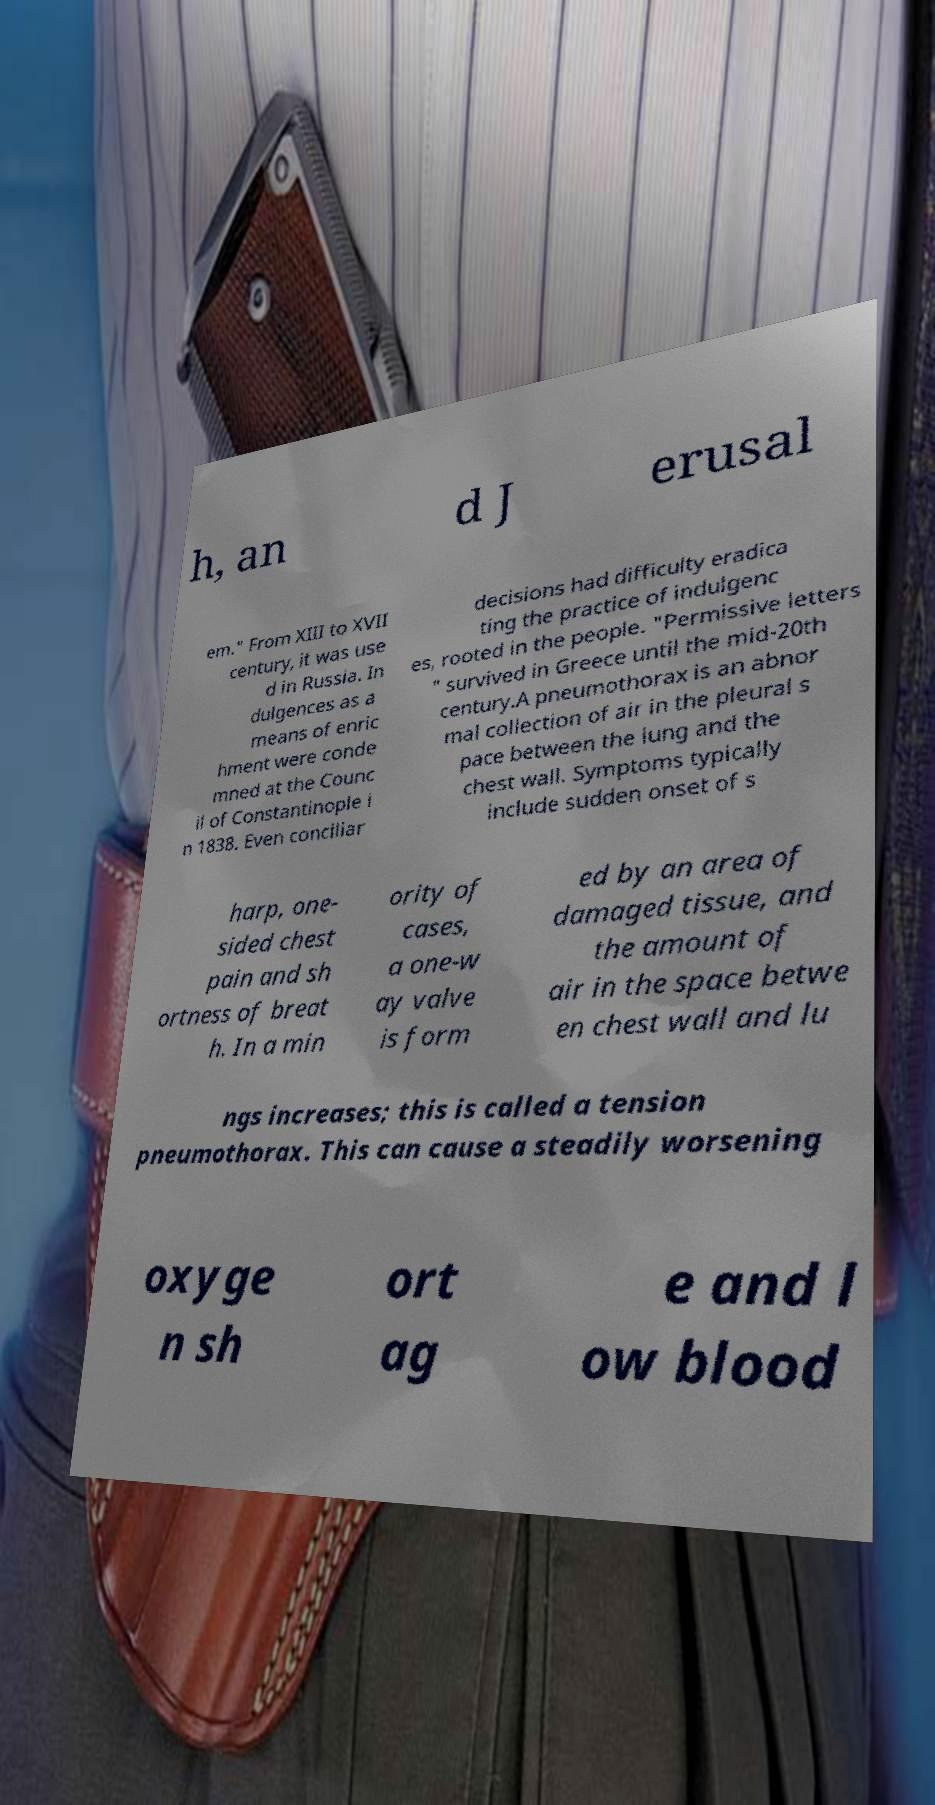There's text embedded in this image that I need extracted. Can you transcribe it verbatim? h, an d J erusal em." From XIII to XVII century, it was use d in Russia. In dulgences as a means of enric hment were conde mned at the Counc il of Constantinople i n 1838. Even conciliar decisions had difficulty eradica ting the practice of indulgenc es, rooted in the people. "Permissive letters " survived in Greece until the mid-20th century.A pneumothorax is an abnor mal collection of air in the pleural s pace between the lung and the chest wall. Symptoms typically include sudden onset of s harp, one- sided chest pain and sh ortness of breat h. In a min ority of cases, a one-w ay valve is form ed by an area of damaged tissue, and the amount of air in the space betwe en chest wall and lu ngs increases; this is called a tension pneumothorax. This can cause a steadily worsening oxyge n sh ort ag e and l ow blood 